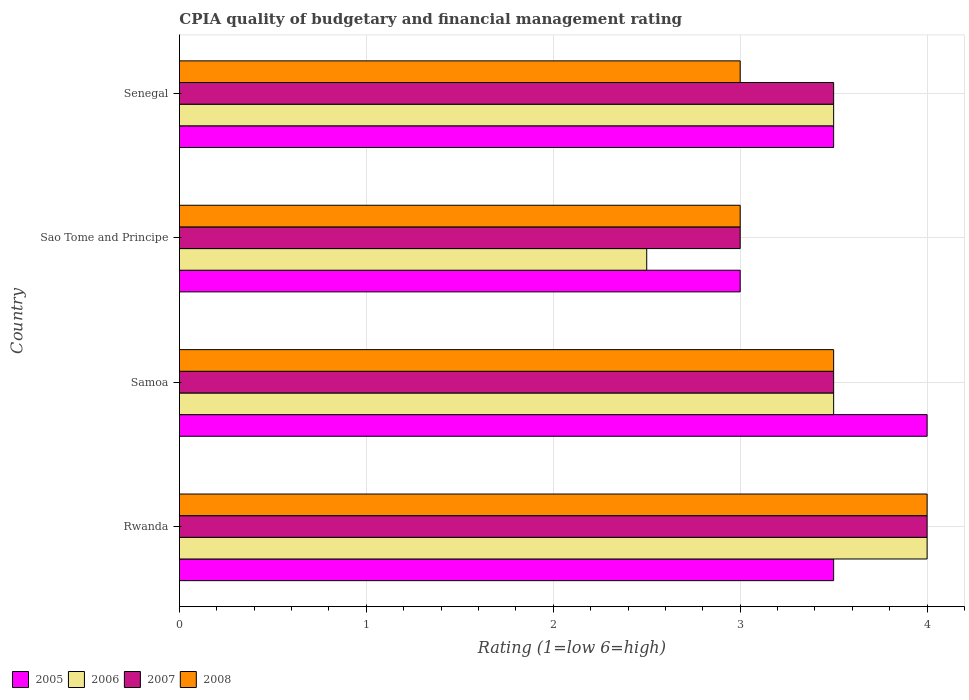How many different coloured bars are there?
Your answer should be compact. 4. How many groups of bars are there?
Your answer should be very brief. 4. Are the number of bars per tick equal to the number of legend labels?
Offer a very short reply. Yes. Are the number of bars on each tick of the Y-axis equal?
Ensure brevity in your answer.  Yes. What is the label of the 1st group of bars from the top?
Make the answer very short. Senegal. In how many cases, is the number of bars for a given country not equal to the number of legend labels?
Ensure brevity in your answer.  0. What is the CPIA rating in 2006 in Samoa?
Make the answer very short. 3.5. Across all countries, what is the minimum CPIA rating in 2005?
Give a very brief answer. 3. In which country was the CPIA rating in 2005 maximum?
Ensure brevity in your answer.  Samoa. In which country was the CPIA rating in 2006 minimum?
Your response must be concise. Sao Tome and Principe. What is the difference between the CPIA rating in 2005 in Rwanda and that in Samoa?
Offer a very short reply. -0.5. What is the difference between the CPIA rating in 2007 and CPIA rating in 2006 in Samoa?
Give a very brief answer. 0. In how many countries, is the CPIA rating in 2007 greater than 0.2 ?
Your answer should be compact. 4. What is the ratio of the CPIA rating in 2008 in Rwanda to that in Samoa?
Ensure brevity in your answer.  1.14. Is the CPIA rating in 2006 in Samoa less than that in Sao Tome and Principe?
Make the answer very short. No. What is the difference between the highest and the second highest CPIA rating in 2007?
Ensure brevity in your answer.  0.5. In how many countries, is the CPIA rating in 2007 greater than the average CPIA rating in 2007 taken over all countries?
Your answer should be very brief. 1. What does the 2nd bar from the top in Samoa represents?
Offer a very short reply. 2007. Are all the bars in the graph horizontal?
Offer a very short reply. Yes. How many countries are there in the graph?
Give a very brief answer. 4. What is the difference between two consecutive major ticks on the X-axis?
Offer a terse response. 1. Does the graph contain any zero values?
Give a very brief answer. No. How many legend labels are there?
Provide a succinct answer. 4. What is the title of the graph?
Offer a terse response. CPIA quality of budgetary and financial management rating. What is the label or title of the X-axis?
Offer a terse response. Rating (1=low 6=high). What is the label or title of the Y-axis?
Offer a terse response. Country. What is the Rating (1=low 6=high) in 2008 in Rwanda?
Provide a succinct answer. 4. What is the Rating (1=low 6=high) of 2006 in Samoa?
Offer a terse response. 3.5. What is the Rating (1=low 6=high) of 2007 in Samoa?
Give a very brief answer. 3.5. What is the Rating (1=low 6=high) of 2005 in Sao Tome and Principe?
Your response must be concise. 3. What is the Rating (1=low 6=high) in 2007 in Sao Tome and Principe?
Provide a short and direct response. 3. What is the Rating (1=low 6=high) of 2005 in Senegal?
Give a very brief answer. 3.5. What is the Rating (1=low 6=high) in 2006 in Senegal?
Give a very brief answer. 3.5. Across all countries, what is the maximum Rating (1=low 6=high) of 2005?
Provide a succinct answer. 4. Across all countries, what is the minimum Rating (1=low 6=high) of 2008?
Offer a very short reply. 3. What is the total Rating (1=low 6=high) of 2007 in the graph?
Keep it short and to the point. 14. What is the difference between the Rating (1=low 6=high) of 2005 in Rwanda and that in Samoa?
Provide a short and direct response. -0.5. What is the difference between the Rating (1=low 6=high) of 2006 in Rwanda and that in Samoa?
Your answer should be compact. 0.5. What is the difference between the Rating (1=low 6=high) in 2007 in Rwanda and that in Samoa?
Your answer should be compact. 0.5. What is the difference between the Rating (1=low 6=high) in 2008 in Rwanda and that in Samoa?
Provide a succinct answer. 0.5. What is the difference between the Rating (1=low 6=high) in 2005 in Rwanda and that in Sao Tome and Principe?
Keep it short and to the point. 0.5. What is the difference between the Rating (1=low 6=high) of 2006 in Rwanda and that in Sao Tome and Principe?
Offer a very short reply. 1.5. What is the difference between the Rating (1=low 6=high) in 2007 in Rwanda and that in Sao Tome and Principe?
Offer a very short reply. 1. What is the difference between the Rating (1=low 6=high) in 2005 in Rwanda and that in Senegal?
Ensure brevity in your answer.  0. What is the difference between the Rating (1=low 6=high) in 2007 in Rwanda and that in Senegal?
Keep it short and to the point. 0.5. What is the difference between the Rating (1=low 6=high) of 2006 in Samoa and that in Sao Tome and Principe?
Give a very brief answer. 1. What is the difference between the Rating (1=low 6=high) of 2007 in Samoa and that in Sao Tome and Principe?
Provide a short and direct response. 0.5. What is the difference between the Rating (1=low 6=high) in 2008 in Samoa and that in Sao Tome and Principe?
Offer a terse response. 0.5. What is the difference between the Rating (1=low 6=high) of 2007 in Samoa and that in Senegal?
Your response must be concise. 0. What is the difference between the Rating (1=low 6=high) in 2005 in Sao Tome and Principe and that in Senegal?
Your answer should be compact. -0.5. What is the difference between the Rating (1=low 6=high) in 2007 in Sao Tome and Principe and that in Senegal?
Offer a very short reply. -0.5. What is the difference between the Rating (1=low 6=high) in 2008 in Sao Tome and Principe and that in Senegal?
Your answer should be compact. 0. What is the difference between the Rating (1=low 6=high) in 2005 in Rwanda and the Rating (1=low 6=high) in 2006 in Samoa?
Your answer should be very brief. 0. What is the difference between the Rating (1=low 6=high) of 2007 in Rwanda and the Rating (1=low 6=high) of 2008 in Samoa?
Provide a short and direct response. 0.5. What is the difference between the Rating (1=low 6=high) in 2005 in Rwanda and the Rating (1=low 6=high) in 2006 in Sao Tome and Principe?
Provide a succinct answer. 1. What is the difference between the Rating (1=low 6=high) of 2005 in Rwanda and the Rating (1=low 6=high) of 2007 in Sao Tome and Principe?
Provide a short and direct response. 0.5. What is the difference between the Rating (1=low 6=high) of 2005 in Rwanda and the Rating (1=low 6=high) of 2008 in Sao Tome and Principe?
Offer a terse response. 0.5. What is the difference between the Rating (1=low 6=high) of 2006 in Rwanda and the Rating (1=low 6=high) of 2007 in Sao Tome and Principe?
Your answer should be very brief. 1. What is the difference between the Rating (1=low 6=high) of 2007 in Rwanda and the Rating (1=low 6=high) of 2008 in Sao Tome and Principe?
Make the answer very short. 1. What is the difference between the Rating (1=low 6=high) of 2005 in Rwanda and the Rating (1=low 6=high) of 2008 in Senegal?
Your answer should be compact. 0.5. What is the difference between the Rating (1=low 6=high) in 2006 in Rwanda and the Rating (1=low 6=high) in 2007 in Senegal?
Provide a short and direct response. 0.5. What is the difference between the Rating (1=low 6=high) of 2006 in Rwanda and the Rating (1=low 6=high) of 2008 in Senegal?
Keep it short and to the point. 1. What is the difference between the Rating (1=low 6=high) of 2007 in Rwanda and the Rating (1=low 6=high) of 2008 in Senegal?
Make the answer very short. 1. What is the difference between the Rating (1=low 6=high) in 2005 in Samoa and the Rating (1=low 6=high) in 2007 in Sao Tome and Principe?
Make the answer very short. 1. What is the difference between the Rating (1=low 6=high) in 2005 in Samoa and the Rating (1=low 6=high) in 2008 in Sao Tome and Principe?
Your answer should be compact. 1. What is the difference between the Rating (1=low 6=high) of 2006 in Samoa and the Rating (1=low 6=high) of 2007 in Sao Tome and Principe?
Keep it short and to the point. 0.5. What is the difference between the Rating (1=low 6=high) in 2006 in Samoa and the Rating (1=low 6=high) in 2008 in Sao Tome and Principe?
Offer a terse response. 0.5. What is the difference between the Rating (1=low 6=high) of 2005 in Samoa and the Rating (1=low 6=high) of 2006 in Senegal?
Offer a very short reply. 0.5. What is the difference between the Rating (1=low 6=high) in 2005 in Samoa and the Rating (1=low 6=high) in 2007 in Senegal?
Keep it short and to the point. 0.5. What is the difference between the Rating (1=low 6=high) of 2007 in Samoa and the Rating (1=low 6=high) of 2008 in Senegal?
Your answer should be compact. 0.5. What is the difference between the Rating (1=low 6=high) in 2005 in Sao Tome and Principe and the Rating (1=low 6=high) in 2007 in Senegal?
Make the answer very short. -0.5. What is the difference between the Rating (1=low 6=high) of 2005 in Sao Tome and Principe and the Rating (1=low 6=high) of 2008 in Senegal?
Offer a very short reply. 0. What is the difference between the Rating (1=low 6=high) of 2007 in Sao Tome and Principe and the Rating (1=low 6=high) of 2008 in Senegal?
Your response must be concise. 0. What is the average Rating (1=low 6=high) in 2005 per country?
Keep it short and to the point. 3.5. What is the average Rating (1=low 6=high) in 2006 per country?
Your answer should be very brief. 3.38. What is the average Rating (1=low 6=high) of 2007 per country?
Make the answer very short. 3.5. What is the average Rating (1=low 6=high) of 2008 per country?
Provide a short and direct response. 3.38. What is the difference between the Rating (1=low 6=high) of 2005 and Rating (1=low 6=high) of 2007 in Rwanda?
Provide a short and direct response. -0.5. What is the difference between the Rating (1=low 6=high) of 2006 and Rating (1=low 6=high) of 2007 in Rwanda?
Your answer should be very brief. 0. What is the difference between the Rating (1=low 6=high) in 2007 and Rating (1=low 6=high) in 2008 in Rwanda?
Your response must be concise. 0. What is the difference between the Rating (1=low 6=high) of 2005 and Rating (1=low 6=high) of 2006 in Samoa?
Your answer should be very brief. 0.5. What is the difference between the Rating (1=low 6=high) of 2005 and Rating (1=low 6=high) of 2008 in Samoa?
Keep it short and to the point. 0.5. What is the difference between the Rating (1=low 6=high) in 2006 and Rating (1=low 6=high) in 2008 in Samoa?
Offer a terse response. 0. What is the difference between the Rating (1=low 6=high) in 2005 and Rating (1=low 6=high) in 2006 in Sao Tome and Principe?
Your answer should be very brief. 0.5. What is the difference between the Rating (1=low 6=high) in 2005 and Rating (1=low 6=high) in 2007 in Sao Tome and Principe?
Provide a succinct answer. 0. What is the difference between the Rating (1=low 6=high) in 2006 and Rating (1=low 6=high) in 2007 in Sao Tome and Principe?
Your answer should be compact. -0.5. What is the difference between the Rating (1=low 6=high) in 2007 and Rating (1=low 6=high) in 2008 in Sao Tome and Principe?
Ensure brevity in your answer.  0. What is the difference between the Rating (1=low 6=high) in 2005 and Rating (1=low 6=high) in 2007 in Senegal?
Offer a terse response. 0. What is the difference between the Rating (1=low 6=high) of 2006 and Rating (1=low 6=high) of 2008 in Senegal?
Your response must be concise. 0.5. What is the difference between the Rating (1=low 6=high) of 2007 and Rating (1=low 6=high) of 2008 in Senegal?
Your response must be concise. 0.5. What is the ratio of the Rating (1=low 6=high) of 2005 in Rwanda to that in Samoa?
Your answer should be very brief. 0.88. What is the ratio of the Rating (1=low 6=high) of 2008 in Rwanda to that in Samoa?
Offer a very short reply. 1.14. What is the ratio of the Rating (1=low 6=high) of 2007 in Rwanda to that in Sao Tome and Principe?
Offer a very short reply. 1.33. What is the ratio of the Rating (1=low 6=high) in 2006 in Rwanda to that in Senegal?
Ensure brevity in your answer.  1.14. What is the ratio of the Rating (1=low 6=high) in 2008 in Rwanda to that in Senegal?
Keep it short and to the point. 1.33. What is the ratio of the Rating (1=low 6=high) in 2006 in Samoa to that in Sao Tome and Principe?
Offer a very short reply. 1.4. What is the ratio of the Rating (1=low 6=high) of 2006 in Samoa to that in Senegal?
Make the answer very short. 1. What is the ratio of the Rating (1=low 6=high) in 2007 in Samoa to that in Senegal?
Your answer should be compact. 1. What is the ratio of the Rating (1=low 6=high) in 2006 in Sao Tome and Principe to that in Senegal?
Give a very brief answer. 0.71. What is the ratio of the Rating (1=low 6=high) in 2007 in Sao Tome and Principe to that in Senegal?
Your answer should be very brief. 0.86. What is the ratio of the Rating (1=low 6=high) in 2008 in Sao Tome and Principe to that in Senegal?
Keep it short and to the point. 1. What is the difference between the highest and the second highest Rating (1=low 6=high) of 2005?
Provide a succinct answer. 0.5. What is the difference between the highest and the second highest Rating (1=low 6=high) in 2006?
Make the answer very short. 0.5. What is the difference between the highest and the second highest Rating (1=low 6=high) in 2007?
Give a very brief answer. 0.5. What is the difference between the highest and the lowest Rating (1=low 6=high) of 2007?
Ensure brevity in your answer.  1. What is the difference between the highest and the lowest Rating (1=low 6=high) in 2008?
Make the answer very short. 1. 